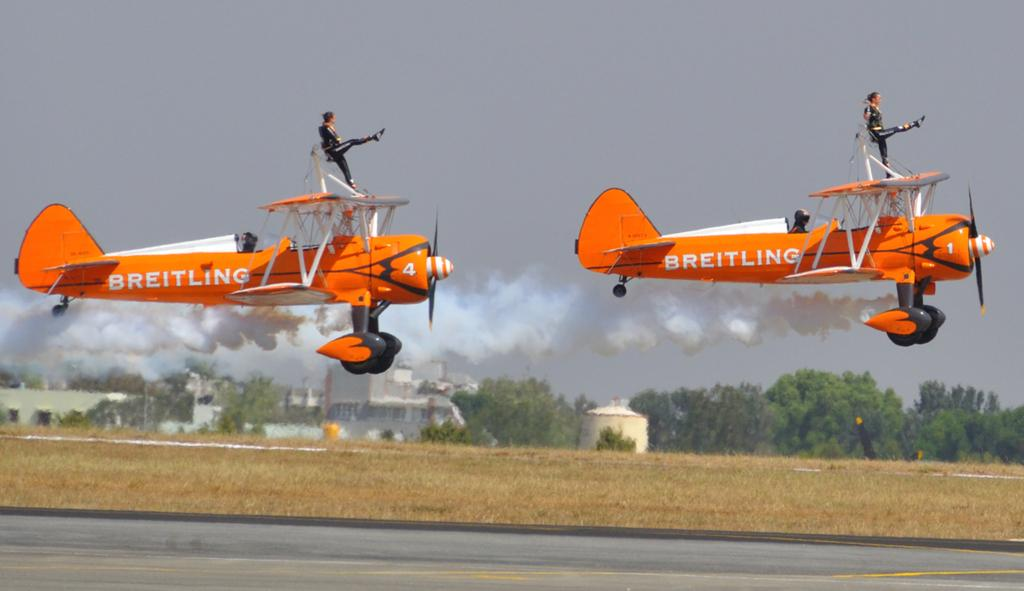<image>
Relay a brief, clear account of the picture shown. Someone stands on an orange plane with Breitling on the side. 